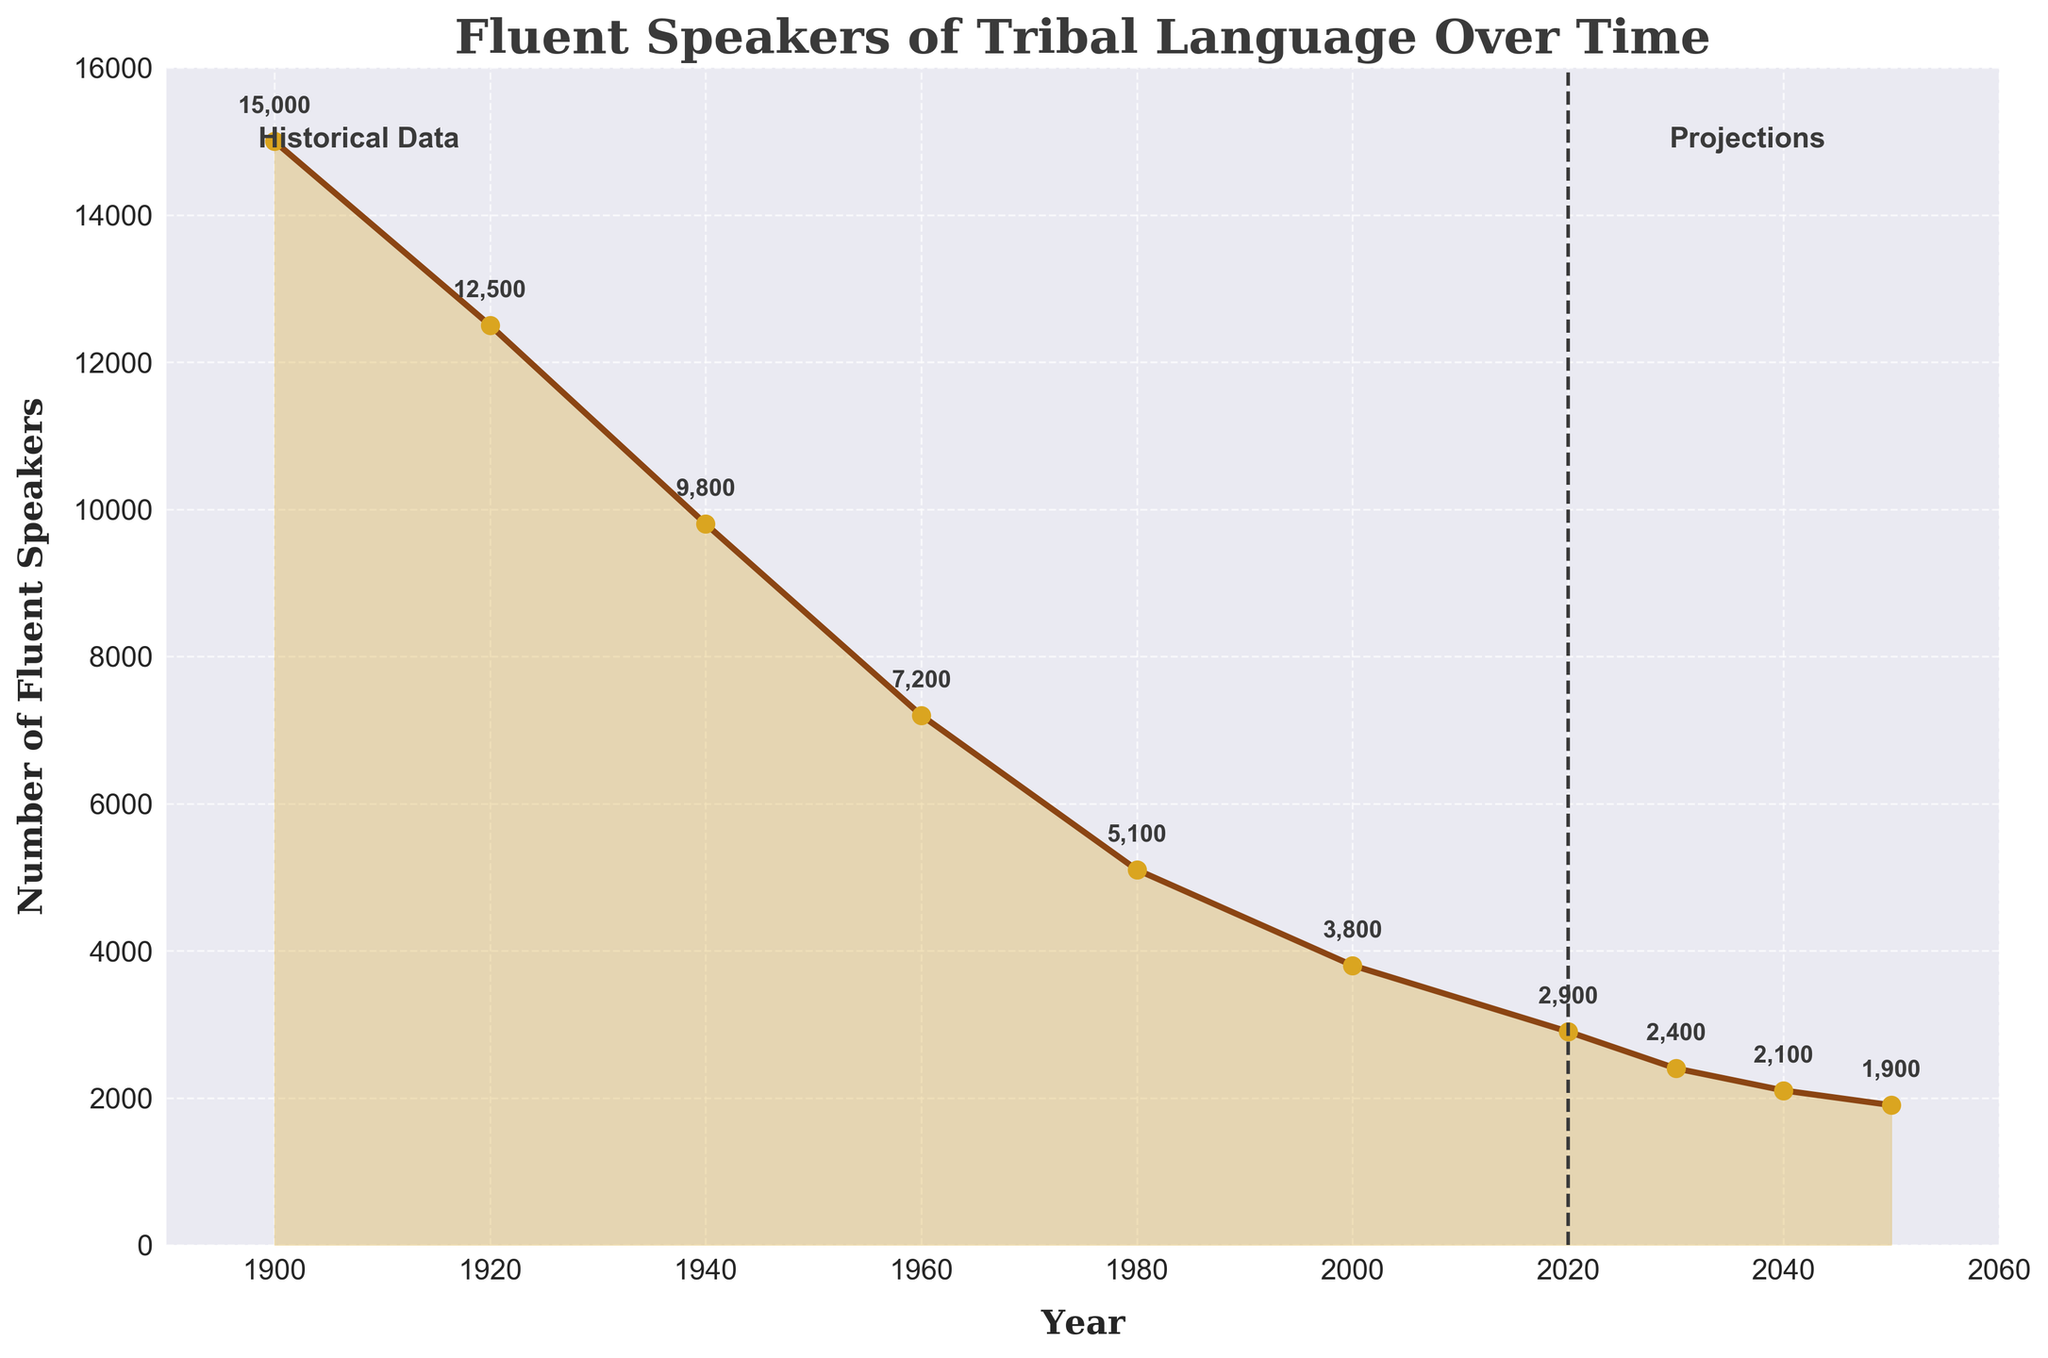How many fluent speakers were there in 2000 and how many are projected to be there in 2050? Look at the values on the line corresponding to the years 2000 and 2050. The fluent speakers in 2000 were 3800 and in 2050 are projected to be 1900.
Answer: 3800 in 2000, 1900 in 2050 Between which two consecutive decades did the number of fluent speakers decrease the most? Calculate the differences between every two consecutive decades. The largest decrease occurred between 1940 (9800) and 1960 (7200) which is 9800 - 7200 = 2600.
Answer: 1940 and 1960 What is the average number of fluent speakers per decade between 1900 and 1980? The numbers are 15000 (1900), 12500 (1920), 9800 (1940), 7200 (1960), and 5100 (1980). Sum them up and divide by 5. (15000 + 12500 + 9800 + 7200 + 5100) / 5 = 9940.
Answer: 9940 Which decade had the least number of fluent speakers in the historical data? Check the values for each decade from 1900 to 2020. The lowest number is 2900 in 2020.
Answer: 2020 What is the difference in the number of fluent speakers between 1900 and 2020? Subtract the number of speakers in 2020 from the number in 1900. 15000 - 2900 = 12100.
Answer: 12100 Describe the color used for the line representing the number of fluent speakers. The line is brown with golden markers highlighting each data point.
Answer: Brown with golden markers Is the trend of the number of fluent speakers increasing or decreasing over time? The overall trend shows a continuous decline in the number of fluent speakers from 1900 to 2050.
Answer: Decreasing What is the projected difference in the number of fluent speakers between 2020 and 2050? Subtract the projected number in 2050 from the number in 2020. 2900 - 1900 = 1000.
Answer: 1000 What annotations are used to separate historical data from projections? The chart uses a dashed vertical line at 2020 and text annotations 'Historical Data' and 'Projections' to separate the historical data from future projections.
Answer: Dashed vertical line at 2020 and text annotations 'Historical Data' and 'Projections' 